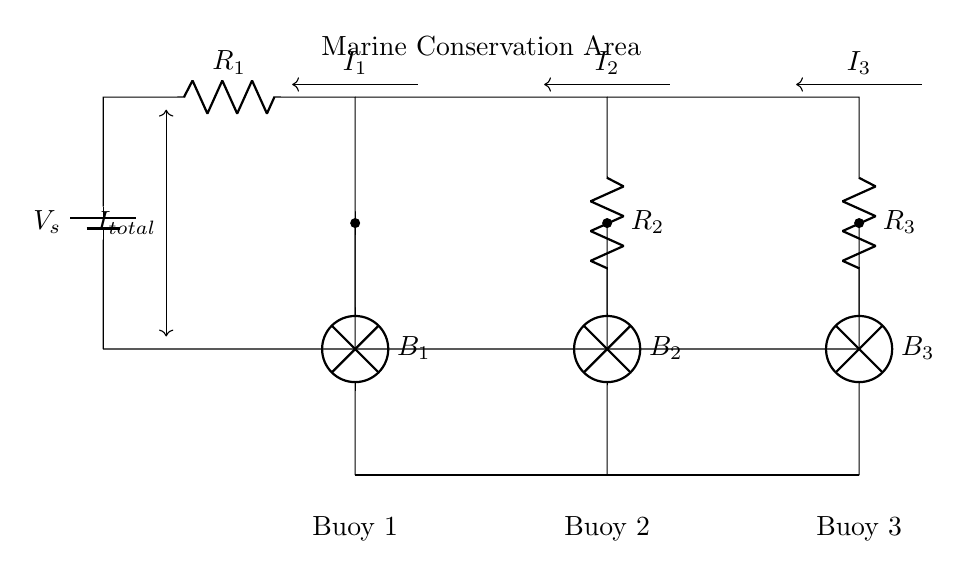What is the source voltage in this circuit? The source voltage, denoted as V_s in the circuit, represents the potential difference providing power to the circuit. This is typically marked at the topmost position, connecting to the resistor network.
Answer: V_s How many resistors are in this circuit? The circuit diagram shows three resistors labeled R_1, R_2, and R_3, connected in parallel to the voltage source.
Answer: 3 Which buoy receives the least current? To determine which buoy receives the least current, we must look at the resistors in parallel; the one with the highest resistance will allow lower current through it, according to Ohm's law. Since current divides inversely with resistance, if R_3 is the largest, then Buoy 3 will receive the least current.
Answer: Buoy 3 What is the total current flowing into the circuit? The total current, denoted as I_total, is indicated by the arrow entering the circuit from the battery. This total current is the sum of the individual currents flowing through each branch, which can be analyzed using the current divider principle.
Answer: I_total What type of circuit configuration is this? The circuit consists of multiple branches where the total current divides, making it a specific kind of parallel circuit known for its current division characteristics. This is evident from the connections and layout involving multiple paths for the current.
Answer: Parallel What do the lamps represent in this circuit? The lamps labeled B_1, B_2, and B_3 signify visual indicators that show the operation of the circuit, indicating that the electrical flow is reaching the respective buoys. The lamps turn on when there is sufficient current flowing through their respective branches.
Answer: Buoy signals 